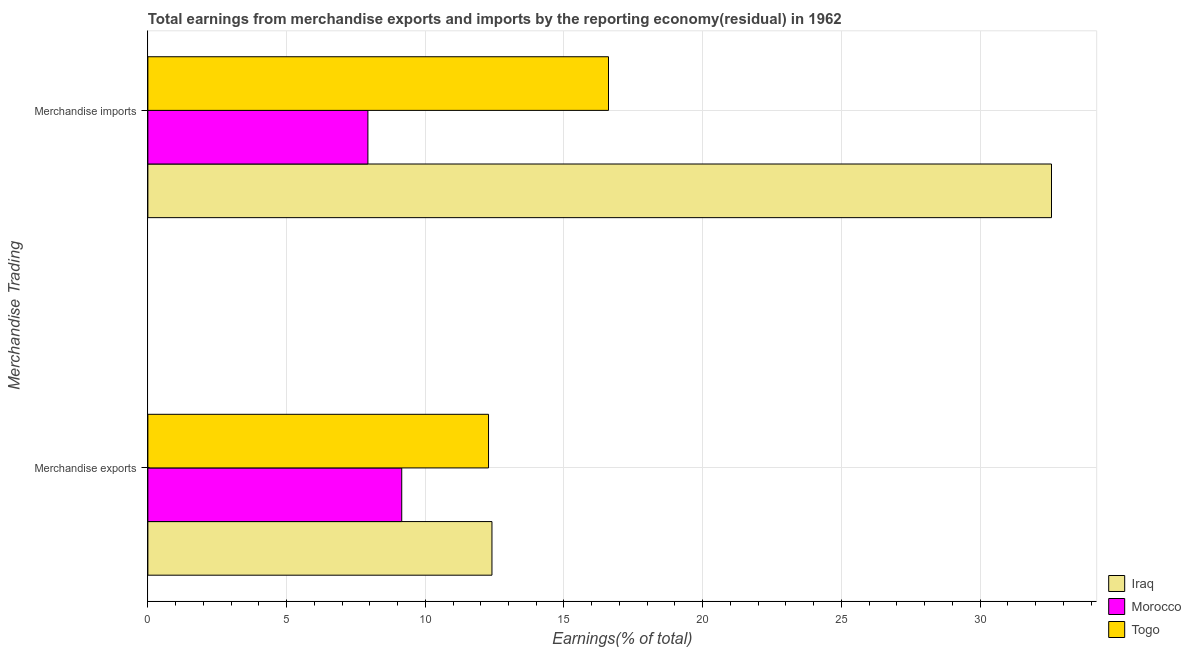Are the number of bars per tick equal to the number of legend labels?
Give a very brief answer. Yes. Are the number of bars on each tick of the Y-axis equal?
Your response must be concise. Yes. How many bars are there on the 1st tick from the bottom?
Offer a terse response. 3. What is the label of the 1st group of bars from the top?
Your answer should be compact. Merchandise imports. What is the earnings from merchandise imports in Iraq?
Ensure brevity in your answer.  32.58. Across all countries, what is the maximum earnings from merchandise exports?
Provide a short and direct response. 12.4. Across all countries, what is the minimum earnings from merchandise imports?
Offer a terse response. 7.93. In which country was the earnings from merchandise imports maximum?
Provide a succinct answer. Iraq. In which country was the earnings from merchandise exports minimum?
Give a very brief answer. Morocco. What is the total earnings from merchandise exports in the graph?
Give a very brief answer. 33.84. What is the difference between the earnings from merchandise exports in Iraq and that in Togo?
Give a very brief answer. 0.12. What is the difference between the earnings from merchandise exports in Togo and the earnings from merchandise imports in Iraq?
Your response must be concise. -20.29. What is the average earnings from merchandise exports per country?
Give a very brief answer. 11.28. What is the difference between the earnings from merchandise imports and earnings from merchandise exports in Iraq?
Your answer should be very brief. 20.17. In how many countries, is the earnings from merchandise imports greater than 1 %?
Make the answer very short. 3. What is the ratio of the earnings from merchandise exports in Togo to that in Morocco?
Provide a short and direct response. 1.34. What does the 1st bar from the top in Merchandise exports represents?
Give a very brief answer. Togo. What does the 1st bar from the bottom in Merchandise exports represents?
Offer a very short reply. Iraq. How many bars are there?
Offer a terse response. 6. What is the difference between two consecutive major ticks on the X-axis?
Provide a short and direct response. 5. Does the graph contain grids?
Give a very brief answer. Yes. Where does the legend appear in the graph?
Your response must be concise. Bottom right. How are the legend labels stacked?
Your response must be concise. Vertical. What is the title of the graph?
Your answer should be compact. Total earnings from merchandise exports and imports by the reporting economy(residual) in 1962. Does "Antigua and Barbuda" appear as one of the legend labels in the graph?
Your response must be concise. No. What is the label or title of the X-axis?
Offer a terse response. Earnings(% of total). What is the label or title of the Y-axis?
Offer a very short reply. Merchandise Trading. What is the Earnings(% of total) in Iraq in Merchandise exports?
Your response must be concise. 12.4. What is the Earnings(% of total) of Morocco in Merchandise exports?
Your response must be concise. 9.15. What is the Earnings(% of total) in Togo in Merchandise exports?
Your answer should be compact. 12.28. What is the Earnings(% of total) of Iraq in Merchandise imports?
Keep it short and to the point. 32.58. What is the Earnings(% of total) of Morocco in Merchandise imports?
Ensure brevity in your answer.  7.93. What is the Earnings(% of total) of Togo in Merchandise imports?
Offer a very short reply. 16.61. Across all Merchandise Trading, what is the maximum Earnings(% of total) in Iraq?
Make the answer very short. 32.58. Across all Merchandise Trading, what is the maximum Earnings(% of total) of Morocco?
Your answer should be compact. 9.15. Across all Merchandise Trading, what is the maximum Earnings(% of total) of Togo?
Ensure brevity in your answer.  16.61. Across all Merchandise Trading, what is the minimum Earnings(% of total) in Iraq?
Ensure brevity in your answer.  12.4. Across all Merchandise Trading, what is the minimum Earnings(% of total) in Morocco?
Offer a very short reply. 7.93. Across all Merchandise Trading, what is the minimum Earnings(% of total) in Togo?
Make the answer very short. 12.28. What is the total Earnings(% of total) of Iraq in the graph?
Your answer should be compact. 44.98. What is the total Earnings(% of total) in Morocco in the graph?
Your answer should be compact. 17.08. What is the total Earnings(% of total) of Togo in the graph?
Give a very brief answer. 28.89. What is the difference between the Earnings(% of total) in Iraq in Merchandise exports and that in Merchandise imports?
Give a very brief answer. -20.17. What is the difference between the Earnings(% of total) in Morocco in Merchandise exports and that in Merchandise imports?
Your answer should be very brief. 1.22. What is the difference between the Earnings(% of total) of Togo in Merchandise exports and that in Merchandise imports?
Your response must be concise. -4.32. What is the difference between the Earnings(% of total) in Iraq in Merchandise exports and the Earnings(% of total) in Morocco in Merchandise imports?
Provide a succinct answer. 4.47. What is the difference between the Earnings(% of total) in Iraq in Merchandise exports and the Earnings(% of total) in Togo in Merchandise imports?
Offer a terse response. -4.2. What is the difference between the Earnings(% of total) of Morocco in Merchandise exports and the Earnings(% of total) of Togo in Merchandise imports?
Provide a succinct answer. -7.45. What is the average Earnings(% of total) in Iraq per Merchandise Trading?
Offer a terse response. 22.49. What is the average Earnings(% of total) in Morocco per Merchandise Trading?
Offer a very short reply. 8.54. What is the average Earnings(% of total) of Togo per Merchandise Trading?
Your answer should be very brief. 14.44. What is the difference between the Earnings(% of total) in Iraq and Earnings(% of total) in Morocco in Merchandise exports?
Your answer should be very brief. 3.25. What is the difference between the Earnings(% of total) in Iraq and Earnings(% of total) in Togo in Merchandise exports?
Offer a terse response. 0.12. What is the difference between the Earnings(% of total) in Morocco and Earnings(% of total) in Togo in Merchandise exports?
Keep it short and to the point. -3.13. What is the difference between the Earnings(% of total) in Iraq and Earnings(% of total) in Morocco in Merchandise imports?
Give a very brief answer. 24.64. What is the difference between the Earnings(% of total) in Iraq and Earnings(% of total) in Togo in Merchandise imports?
Provide a short and direct response. 15.97. What is the difference between the Earnings(% of total) in Morocco and Earnings(% of total) in Togo in Merchandise imports?
Offer a very short reply. -8.67. What is the ratio of the Earnings(% of total) of Iraq in Merchandise exports to that in Merchandise imports?
Your answer should be compact. 0.38. What is the ratio of the Earnings(% of total) in Morocco in Merchandise exports to that in Merchandise imports?
Your response must be concise. 1.15. What is the ratio of the Earnings(% of total) of Togo in Merchandise exports to that in Merchandise imports?
Provide a succinct answer. 0.74. What is the difference between the highest and the second highest Earnings(% of total) of Iraq?
Keep it short and to the point. 20.17. What is the difference between the highest and the second highest Earnings(% of total) of Morocco?
Ensure brevity in your answer.  1.22. What is the difference between the highest and the second highest Earnings(% of total) in Togo?
Your answer should be very brief. 4.32. What is the difference between the highest and the lowest Earnings(% of total) of Iraq?
Your answer should be compact. 20.17. What is the difference between the highest and the lowest Earnings(% of total) in Morocco?
Provide a short and direct response. 1.22. What is the difference between the highest and the lowest Earnings(% of total) in Togo?
Offer a very short reply. 4.32. 